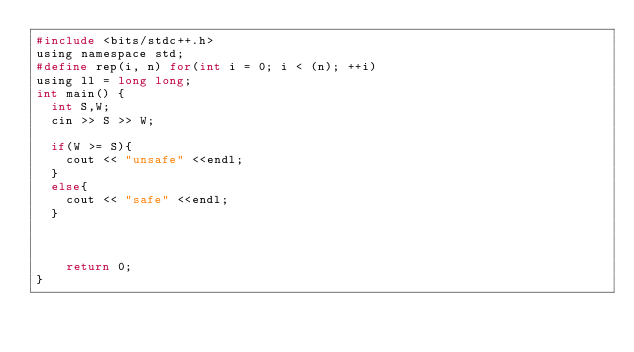<code> <loc_0><loc_0><loc_500><loc_500><_C_>#include <bits/stdc++.h>
using namespace std;
#define rep(i, n) for(int i = 0; i < (n); ++i)
using ll = long long;
int main() {
  int S,W;
  cin >> S >> W;
  
  if(W >= S){
    cout << "unsafe" <<endl;
  }
  else{
    cout << "safe" <<endl;
  }
  
    
  
    return 0;
}</code> 